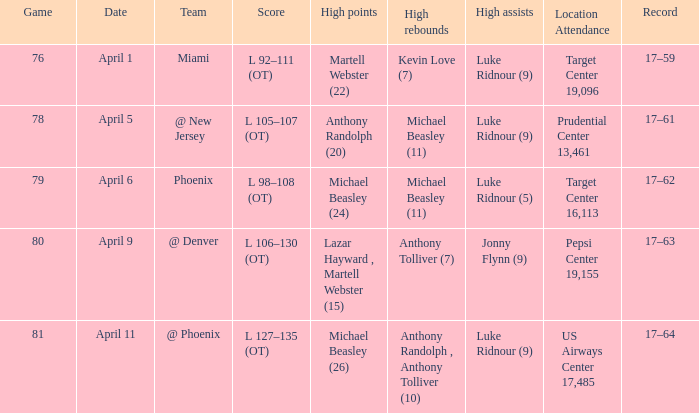In the game where michael beasley scored 26 high points, what was the final score? L 127–135 (OT). 